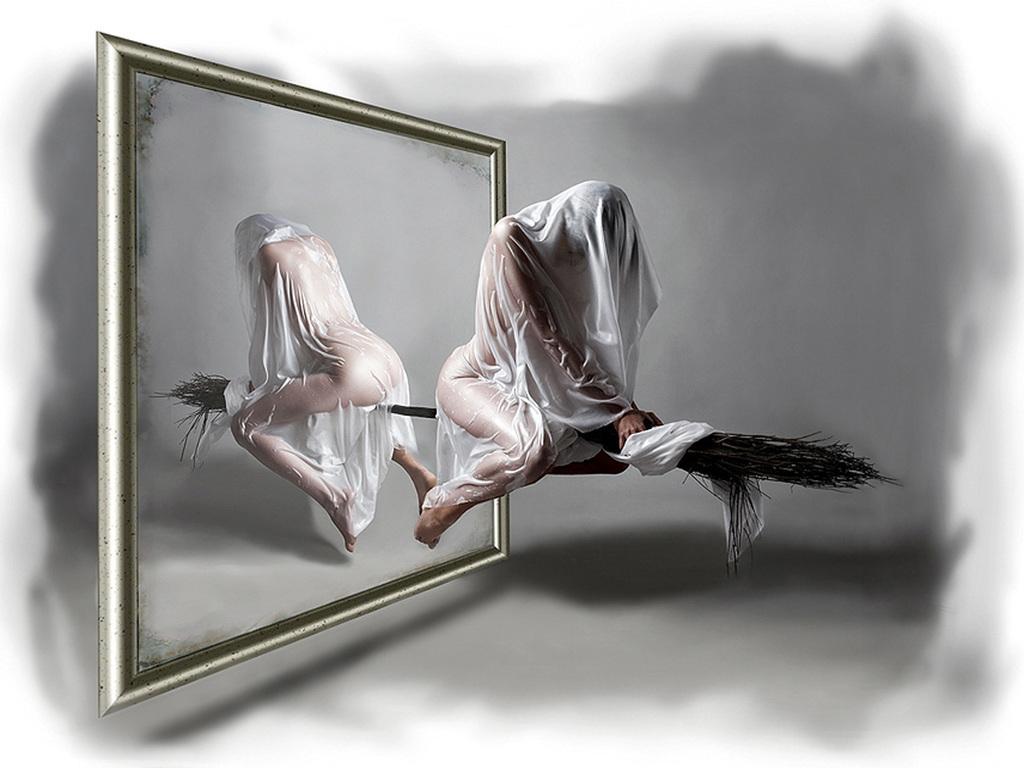How would you summarize this image in a sentence or two? In this image I can see a person sitting on the broomstick. The person is wearing white color cloth, background I can see a frame. 